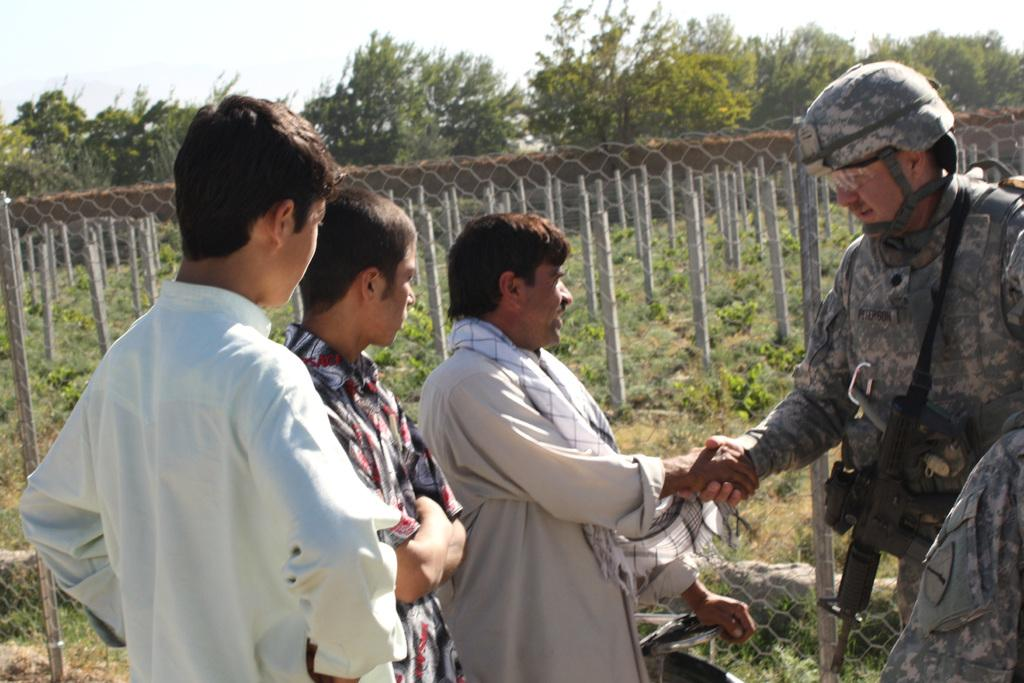How many men are in the foreground of the image? There are two men in the foreground of the image. What are the two men doing in the foreground of the image? The two men are shaking hands in the foreground of the image. What can be seen in the background of the image? In the background of the image, there are poles, fencing, plants, trees, and the sky. What relation does the fact have to the force in the image? There is no mention of a fact or force in the image, so it is not possible to determine any relation between them. 